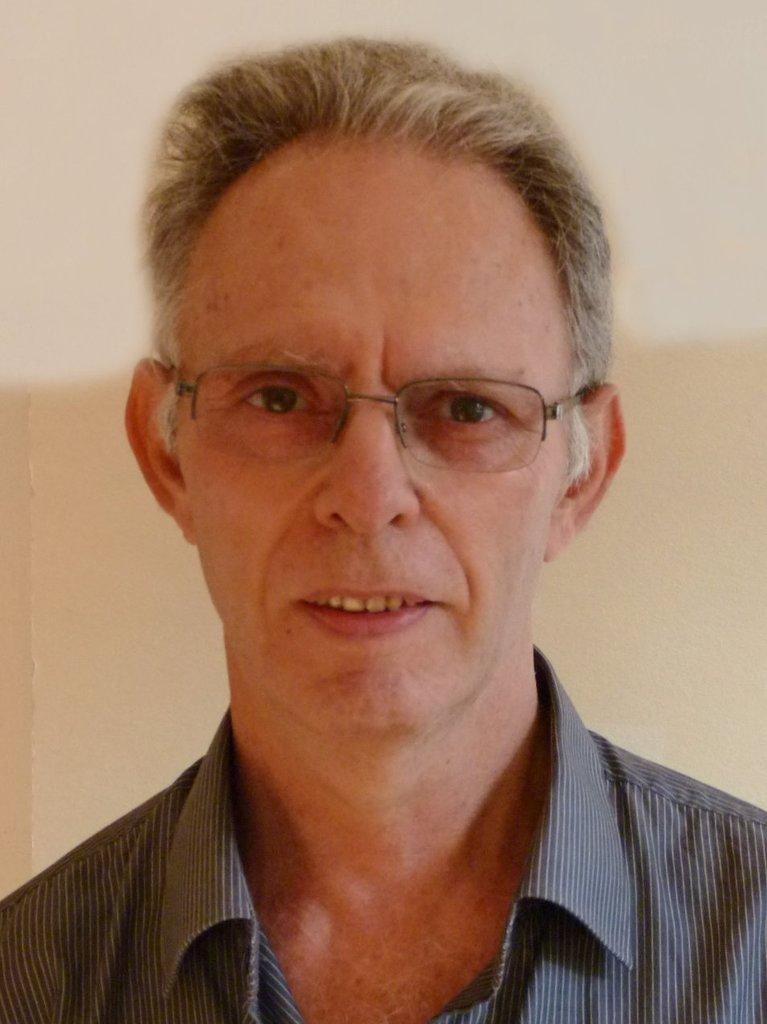What is present in the image? There is a person in the image. What is the person wearing on their upper body? The person is wearing a black shirt. What accessory is the person wearing on their face? The person is wearing spectacles. What can be seen in the background of the image? There is a white and cream colored wall in the background of the image. How many friends are visible in the image? There are no friends visible in the image; it only features one person. What type of sweater is the person wearing in the image? The person is not wearing a sweater in the image; they are wearing a black shirt. 